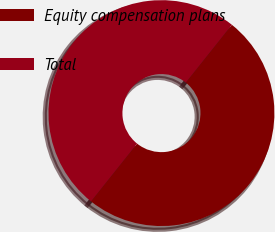<chart> <loc_0><loc_0><loc_500><loc_500><pie_chart><fcel>Equity compensation plans<fcel>Total<nl><fcel>50.0%<fcel>50.0%<nl></chart> 